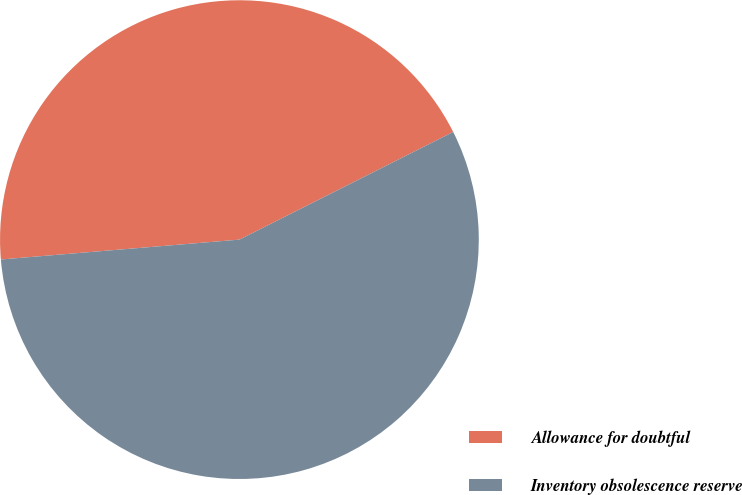<chart> <loc_0><loc_0><loc_500><loc_500><pie_chart><fcel>Allowance for doubtful<fcel>Inventory obsolescence reserve<nl><fcel>43.9%<fcel>56.1%<nl></chart> 